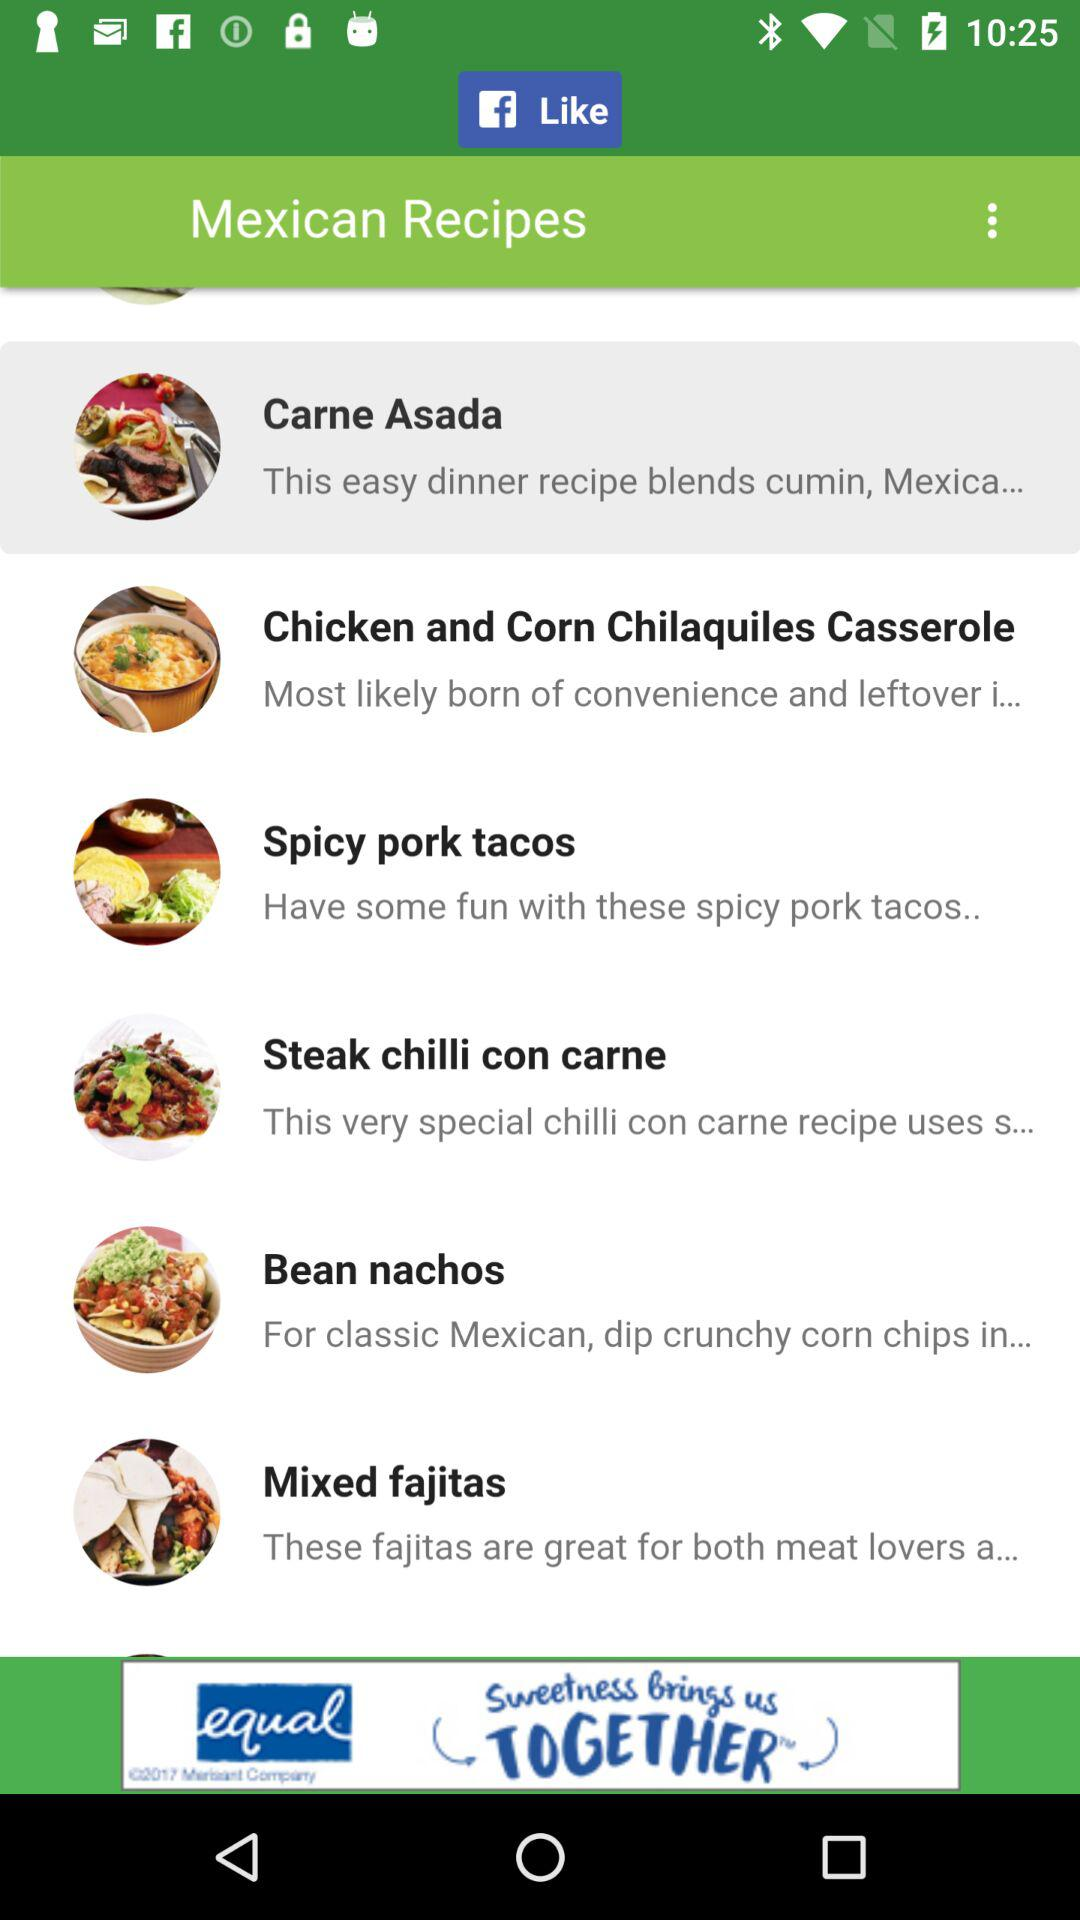How long does it take to make spicy pork tacos?
When the provided information is insufficient, respond with <no answer>. <no answer> 